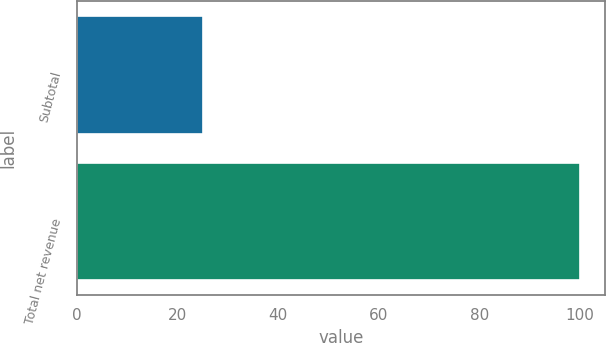<chart> <loc_0><loc_0><loc_500><loc_500><bar_chart><fcel>Subtotal<fcel>Total net revenue<nl><fcel>25<fcel>100<nl></chart> 